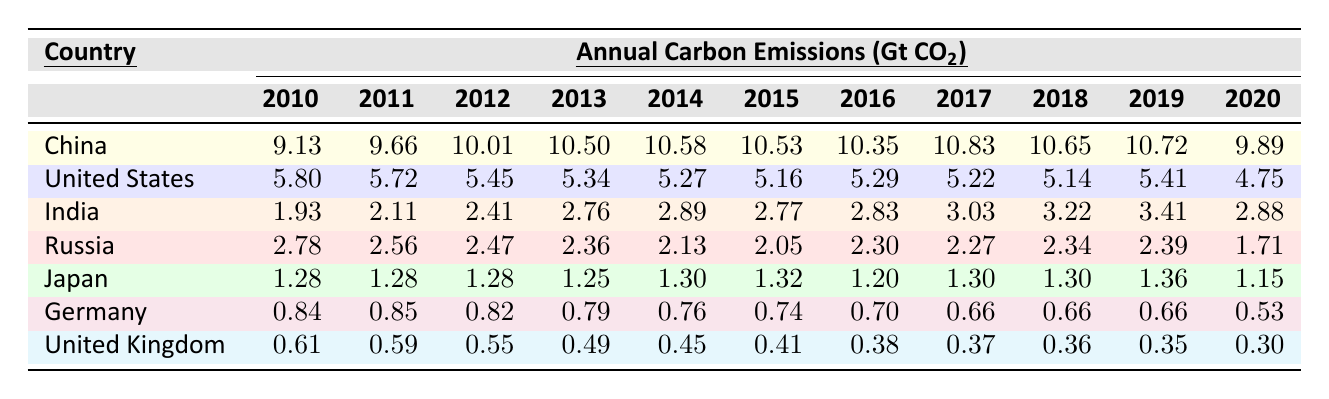What was the highest annual carbon emission in 2012 and which country recorded it? The highest value in 2012 is 10.01 Gt CO2, which is recorded by China.
Answer: 10.01 Gt CO2 by China Which country had the lowest carbon emissions in 2020? In 2020, the lowest carbon emissions were recorded by the United Kingdom at 0.30 Gt CO2.
Answer: United Kingdom What is the average annual carbon emission for India between 2010 and 2020? To find the average for India, we sum the emissions from 2010 to 2020: 1.93 + 2.11 + 2.41 + 2.76 + 2.89 + 2.77 + 2.83 + 3.03 + 3.22 + 3.41 + 2.88 = 28.03, and divide it by 11 (years), giving us 28.03 / 11 ≈ 2.55.
Answer: 2.55 Did carbon emissions in the United States decrease over the years from 2010 to 2020? By checking the data, the emissions started at 5.80 in 2010 and dropped to 4.75 in 2020, indicating a decrease.
Answer: Yes What was the total carbon emission from China over the years 2010 to 2020? Summing the emissions from 2010 to 2020: 9.13 + 9.66 + 10.01 + 10.50 + 10.58 + 10.53 + 10.35 + 10.83 + 10.65 + 10.72 + 9.89 gives a total of 112.92.
Answer: 112.92 Gt CO2 Which country had the most fluctuations in carbon emissions from 2010 to 2020? By analyzing the data, China shows variations peaking at 10.83 in 2017 and dropping to 9.89 in 2020, indicating significant fluctuations, while others show more stable numbers.
Answer: China Was there a year when Germany's emissions were below 0.70 Gt CO2? In 2020, Germany's emissions were recorded at 0.53 Gt CO2, which is below 0.70.
Answer: Yes If we compare the carbon emissions of Russia from 2010 to 2020, did they show a consistent decrease? The data shows that Russia's emissions fluctuated, decreasing to 1.71 in 2020 after peaking at 2.78 in 2010, indicating inconsistency rather than consistency.
Answer: No Which country's emissions in 2016 were lower than the United Kingdom's emissions in the same year? In 2016, the United Kingdom emitted 0.38 Gt CO2. Comparing this to countries like Germany (0.70), Japan (1.20), and Russia (2.30), it shows that emissions for all these countries were higher.
Answer: None What is the difference in carbon emissions between China in 2013 and the United States in 2013? In 2013, China emitted 10.50 Gt CO2 while the United States emitted 5.34 Gt CO2. The difference is 10.50 - 5.34 = 5.16 Gt CO2.
Answer: 5.16 Gt CO2 